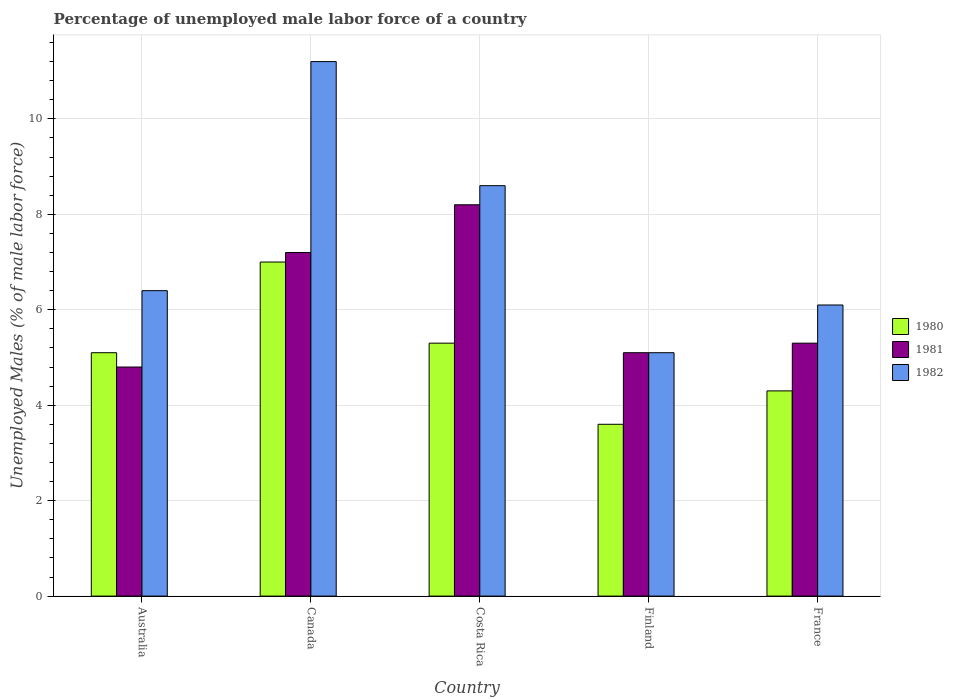How many bars are there on the 4th tick from the right?
Offer a very short reply. 3. What is the label of the 1st group of bars from the left?
Make the answer very short. Australia. In how many cases, is the number of bars for a given country not equal to the number of legend labels?
Make the answer very short. 0. What is the percentage of unemployed male labor force in 1982 in Finland?
Provide a succinct answer. 5.1. Across all countries, what is the maximum percentage of unemployed male labor force in 1980?
Your answer should be compact. 7. Across all countries, what is the minimum percentage of unemployed male labor force in 1980?
Your answer should be very brief. 3.6. In which country was the percentage of unemployed male labor force in 1981 maximum?
Your answer should be compact. Costa Rica. What is the total percentage of unemployed male labor force in 1980 in the graph?
Give a very brief answer. 25.3. What is the difference between the percentage of unemployed male labor force in 1981 in Australia and that in France?
Provide a short and direct response. -0.5. What is the difference between the percentage of unemployed male labor force in 1980 in Canada and the percentage of unemployed male labor force in 1982 in Finland?
Provide a short and direct response. 1.9. What is the average percentage of unemployed male labor force in 1982 per country?
Offer a terse response. 7.48. What is the difference between the percentage of unemployed male labor force of/in 1981 and percentage of unemployed male labor force of/in 1980 in Costa Rica?
Ensure brevity in your answer.  2.9. What is the ratio of the percentage of unemployed male labor force in 1980 in Canada to that in Costa Rica?
Your response must be concise. 1.32. Is the percentage of unemployed male labor force in 1981 in Canada less than that in France?
Your answer should be compact. No. What is the difference between the highest and the second highest percentage of unemployed male labor force in 1982?
Provide a succinct answer. -2.6. What is the difference between the highest and the lowest percentage of unemployed male labor force in 1982?
Your answer should be compact. 6.1. Is the sum of the percentage of unemployed male labor force in 1981 in Australia and France greater than the maximum percentage of unemployed male labor force in 1982 across all countries?
Make the answer very short. No. What does the 3rd bar from the right in Costa Rica represents?
Give a very brief answer. 1980. Is it the case that in every country, the sum of the percentage of unemployed male labor force in 1982 and percentage of unemployed male labor force in 1981 is greater than the percentage of unemployed male labor force in 1980?
Offer a terse response. Yes. How many bars are there?
Offer a terse response. 15. How many countries are there in the graph?
Keep it short and to the point. 5. Are the values on the major ticks of Y-axis written in scientific E-notation?
Ensure brevity in your answer.  No. What is the title of the graph?
Provide a short and direct response. Percentage of unemployed male labor force of a country. What is the label or title of the Y-axis?
Offer a terse response. Unemployed Males (% of male labor force). What is the Unemployed Males (% of male labor force) in 1980 in Australia?
Provide a succinct answer. 5.1. What is the Unemployed Males (% of male labor force) of 1981 in Australia?
Keep it short and to the point. 4.8. What is the Unemployed Males (% of male labor force) in 1982 in Australia?
Offer a terse response. 6.4. What is the Unemployed Males (% of male labor force) in 1980 in Canada?
Keep it short and to the point. 7. What is the Unemployed Males (% of male labor force) of 1981 in Canada?
Make the answer very short. 7.2. What is the Unemployed Males (% of male labor force) in 1982 in Canada?
Your answer should be very brief. 11.2. What is the Unemployed Males (% of male labor force) in 1980 in Costa Rica?
Ensure brevity in your answer.  5.3. What is the Unemployed Males (% of male labor force) in 1981 in Costa Rica?
Ensure brevity in your answer.  8.2. What is the Unemployed Males (% of male labor force) in 1982 in Costa Rica?
Your answer should be very brief. 8.6. What is the Unemployed Males (% of male labor force) in 1980 in Finland?
Ensure brevity in your answer.  3.6. What is the Unemployed Males (% of male labor force) in 1981 in Finland?
Offer a very short reply. 5.1. What is the Unemployed Males (% of male labor force) of 1982 in Finland?
Your response must be concise. 5.1. What is the Unemployed Males (% of male labor force) of 1980 in France?
Keep it short and to the point. 4.3. What is the Unemployed Males (% of male labor force) in 1981 in France?
Offer a very short reply. 5.3. What is the Unemployed Males (% of male labor force) in 1982 in France?
Your answer should be very brief. 6.1. Across all countries, what is the maximum Unemployed Males (% of male labor force) of 1980?
Offer a terse response. 7. Across all countries, what is the maximum Unemployed Males (% of male labor force) in 1981?
Your answer should be very brief. 8.2. Across all countries, what is the maximum Unemployed Males (% of male labor force) of 1982?
Offer a very short reply. 11.2. Across all countries, what is the minimum Unemployed Males (% of male labor force) in 1980?
Give a very brief answer. 3.6. Across all countries, what is the minimum Unemployed Males (% of male labor force) in 1981?
Give a very brief answer. 4.8. Across all countries, what is the minimum Unemployed Males (% of male labor force) in 1982?
Your answer should be compact. 5.1. What is the total Unemployed Males (% of male labor force) in 1980 in the graph?
Your answer should be compact. 25.3. What is the total Unemployed Males (% of male labor force) in 1981 in the graph?
Provide a short and direct response. 30.6. What is the total Unemployed Males (% of male labor force) in 1982 in the graph?
Your answer should be compact. 37.4. What is the difference between the Unemployed Males (% of male labor force) in 1980 in Australia and that in Canada?
Offer a very short reply. -1.9. What is the difference between the Unemployed Males (% of male labor force) of 1981 in Australia and that in Canada?
Your answer should be very brief. -2.4. What is the difference between the Unemployed Males (% of male labor force) in 1982 in Australia and that in Costa Rica?
Your response must be concise. -2.2. What is the difference between the Unemployed Males (% of male labor force) of 1980 in Australia and that in Finland?
Provide a short and direct response. 1.5. What is the difference between the Unemployed Males (% of male labor force) of 1981 in Australia and that in Finland?
Make the answer very short. -0.3. What is the difference between the Unemployed Males (% of male labor force) in 1981 in Australia and that in France?
Keep it short and to the point. -0.5. What is the difference between the Unemployed Males (% of male labor force) in 1982 in Australia and that in France?
Your response must be concise. 0.3. What is the difference between the Unemployed Males (% of male labor force) in 1980 in Canada and that in Costa Rica?
Your response must be concise. 1.7. What is the difference between the Unemployed Males (% of male labor force) of 1982 in Canada and that in Costa Rica?
Your answer should be compact. 2.6. What is the difference between the Unemployed Males (% of male labor force) of 1980 in Canada and that in Finland?
Offer a very short reply. 3.4. What is the difference between the Unemployed Males (% of male labor force) of 1981 in Canada and that in Finland?
Your answer should be compact. 2.1. What is the difference between the Unemployed Males (% of male labor force) of 1982 in Canada and that in Finland?
Provide a succinct answer. 6.1. What is the difference between the Unemployed Males (% of male labor force) in 1982 in Canada and that in France?
Ensure brevity in your answer.  5.1. What is the difference between the Unemployed Males (% of male labor force) in 1982 in Costa Rica and that in Finland?
Offer a terse response. 3.5. What is the difference between the Unemployed Males (% of male labor force) of 1981 in Costa Rica and that in France?
Your response must be concise. 2.9. What is the difference between the Unemployed Males (% of male labor force) in 1981 in Finland and that in France?
Ensure brevity in your answer.  -0.2. What is the difference between the Unemployed Males (% of male labor force) in 1982 in Finland and that in France?
Offer a terse response. -1. What is the difference between the Unemployed Males (% of male labor force) of 1980 in Australia and the Unemployed Males (% of male labor force) of 1982 in Costa Rica?
Offer a terse response. -3.5. What is the difference between the Unemployed Males (% of male labor force) in 1980 in Australia and the Unemployed Males (% of male labor force) in 1982 in Finland?
Your answer should be very brief. 0. What is the difference between the Unemployed Males (% of male labor force) in 1980 in Australia and the Unemployed Males (% of male labor force) in 1982 in France?
Your answer should be compact. -1. What is the difference between the Unemployed Males (% of male labor force) of 1980 in Canada and the Unemployed Males (% of male labor force) of 1981 in Finland?
Give a very brief answer. 1.9. What is the difference between the Unemployed Males (% of male labor force) in 1980 in Canada and the Unemployed Males (% of male labor force) in 1982 in Finland?
Your answer should be very brief. 1.9. What is the difference between the Unemployed Males (% of male labor force) in 1981 in Canada and the Unemployed Males (% of male labor force) in 1982 in Finland?
Keep it short and to the point. 2.1. What is the difference between the Unemployed Males (% of male labor force) in 1980 in Canada and the Unemployed Males (% of male labor force) in 1981 in France?
Give a very brief answer. 1.7. What is the difference between the Unemployed Males (% of male labor force) in 1981 in Canada and the Unemployed Males (% of male labor force) in 1982 in France?
Ensure brevity in your answer.  1.1. What is the difference between the Unemployed Males (% of male labor force) in 1980 in Costa Rica and the Unemployed Males (% of male labor force) in 1981 in Finland?
Offer a very short reply. 0.2. What is the difference between the Unemployed Males (% of male labor force) of 1980 in Costa Rica and the Unemployed Males (% of male labor force) of 1981 in France?
Give a very brief answer. 0. What is the difference between the Unemployed Males (% of male labor force) in 1981 in Costa Rica and the Unemployed Males (% of male labor force) in 1982 in France?
Ensure brevity in your answer.  2.1. What is the difference between the Unemployed Males (% of male labor force) in 1980 in Finland and the Unemployed Males (% of male labor force) in 1981 in France?
Your answer should be compact. -1.7. What is the average Unemployed Males (% of male labor force) in 1980 per country?
Your answer should be very brief. 5.06. What is the average Unemployed Males (% of male labor force) in 1981 per country?
Your answer should be compact. 6.12. What is the average Unemployed Males (% of male labor force) of 1982 per country?
Offer a very short reply. 7.48. What is the difference between the Unemployed Males (% of male labor force) in 1980 and Unemployed Males (% of male labor force) in 1981 in Australia?
Give a very brief answer. 0.3. What is the difference between the Unemployed Males (% of male labor force) of 1980 and Unemployed Males (% of male labor force) of 1982 in Australia?
Make the answer very short. -1.3. What is the difference between the Unemployed Males (% of male labor force) in 1981 and Unemployed Males (% of male labor force) in 1982 in Australia?
Your answer should be very brief. -1.6. What is the difference between the Unemployed Males (% of male labor force) in 1980 and Unemployed Males (% of male labor force) in 1981 in Canada?
Give a very brief answer. -0.2. What is the difference between the Unemployed Males (% of male labor force) in 1980 and Unemployed Males (% of male labor force) in 1982 in Canada?
Provide a short and direct response. -4.2. What is the difference between the Unemployed Males (% of male labor force) in 1981 and Unemployed Males (% of male labor force) in 1982 in Canada?
Your response must be concise. -4. What is the difference between the Unemployed Males (% of male labor force) of 1980 and Unemployed Males (% of male labor force) of 1982 in Costa Rica?
Offer a terse response. -3.3. What is the difference between the Unemployed Males (% of male labor force) in 1980 and Unemployed Males (% of male labor force) in 1982 in Finland?
Your answer should be very brief. -1.5. What is the difference between the Unemployed Males (% of male labor force) of 1980 and Unemployed Males (% of male labor force) of 1981 in France?
Make the answer very short. -1. What is the difference between the Unemployed Males (% of male labor force) of 1980 and Unemployed Males (% of male labor force) of 1982 in France?
Your answer should be compact. -1.8. What is the ratio of the Unemployed Males (% of male labor force) in 1980 in Australia to that in Canada?
Provide a succinct answer. 0.73. What is the ratio of the Unemployed Males (% of male labor force) in 1981 in Australia to that in Canada?
Provide a succinct answer. 0.67. What is the ratio of the Unemployed Males (% of male labor force) in 1980 in Australia to that in Costa Rica?
Your answer should be compact. 0.96. What is the ratio of the Unemployed Males (% of male labor force) of 1981 in Australia to that in Costa Rica?
Keep it short and to the point. 0.59. What is the ratio of the Unemployed Males (% of male labor force) of 1982 in Australia to that in Costa Rica?
Provide a short and direct response. 0.74. What is the ratio of the Unemployed Males (% of male labor force) in 1980 in Australia to that in Finland?
Your answer should be compact. 1.42. What is the ratio of the Unemployed Males (% of male labor force) in 1981 in Australia to that in Finland?
Provide a succinct answer. 0.94. What is the ratio of the Unemployed Males (% of male labor force) of 1982 in Australia to that in Finland?
Keep it short and to the point. 1.25. What is the ratio of the Unemployed Males (% of male labor force) in 1980 in Australia to that in France?
Ensure brevity in your answer.  1.19. What is the ratio of the Unemployed Males (% of male labor force) of 1981 in Australia to that in France?
Provide a succinct answer. 0.91. What is the ratio of the Unemployed Males (% of male labor force) of 1982 in Australia to that in France?
Ensure brevity in your answer.  1.05. What is the ratio of the Unemployed Males (% of male labor force) of 1980 in Canada to that in Costa Rica?
Keep it short and to the point. 1.32. What is the ratio of the Unemployed Males (% of male labor force) in 1981 in Canada to that in Costa Rica?
Make the answer very short. 0.88. What is the ratio of the Unemployed Males (% of male labor force) in 1982 in Canada to that in Costa Rica?
Your answer should be very brief. 1.3. What is the ratio of the Unemployed Males (% of male labor force) of 1980 in Canada to that in Finland?
Provide a short and direct response. 1.94. What is the ratio of the Unemployed Males (% of male labor force) in 1981 in Canada to that in Finland?
Provide a succinct answer. 1.41. What is the ratio of the Unemployed Males (% of male labor force) of 1982 in Canada to that in Finland?
Your answer should be very brief. 2.2. What is the ratio of the Unemployed Males (% of male labor force) of 1980 in Canada to that in France?
Your answer should be compact. 1.63. What is the ratio of the Unemployed Males (% of male labor force) in 1981 in Canada to that in France?
Your answer should be compact. 1.36. What is the ratio of the Unemployed Males (% of male labor force) in 1982 in Canada to that in France?
Provide a succinct answer. 1.84. What is the ratio of the Unemployed Males (% of male labor force) of 1980 in Costa Rica to that in Finland?
Offer a terse response. 1.47. What is the ratio of the Unemployed Males (% of male labor force) in 1981 in Costa Rica to that in Finland?
Your answer should be very brief. 1.61. What is the ratio of the Unemployed Males (% of male labor force) of 1982 in Costa Rica to that in Finland?
Provide a short and direct response. 1.69. What is the ratio of the Unemployed Males (% of male labor force) of 1980 in Costa Rica to that in France?
Your response must be concise. 1.23. What is the ratio of the Unemployed Males (% of male labor force) of 1981 in Costa Rica to that in France?
Keep it short and to the point. 1.55. What is the ratio of the Unemployed Males (% of male labor force) of 1982 in Costa Rica to that in France?
Offer a terse response. 1.41. What is the ratio of the Unemployed Males (% of male labor force) in 1980 in Finland to that in France?
Your answer should be very brief. 0.84. What is the ratio of the Unemployed Males (% of male labor force) in 1981 in Finland to that in France?
Your answer should be compact. 0.96. What is the ratio of the Unemployed Males (% of male labor force) in 1982 in Finland to that in France?
Your answer should be very brief. 0.84. What is the difference between the highest and the second highest Unemployed Males (% of male labor force) in 1981?
Provide a short and direct response. 1. What is the difference between the highest and the second highest Unemployed Males (% of male labor force) in 1982?
Your answer should be very brief. 2.6. What is the difference between the highest and the lowest Unemployed Males (% of male labor force) in 1980?
Offer a very short reply. 3.4. 